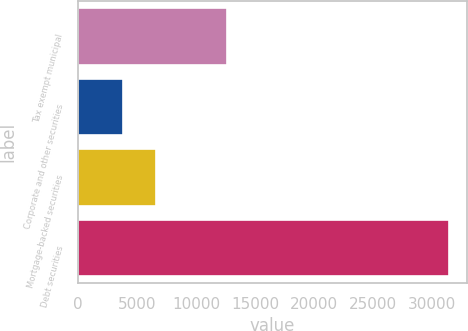<chart> <loc_0><loc_0><loc_500><loc_500><bar_chart><fcel>Tax exempt municipal<fcel>Corporate and other securities<fcel>Mortgage-backed securities<fcel>Debt securities<nl><fcel>12602<fcel>3824<fcel>6582.9<fcel>31413<nl></chart> 